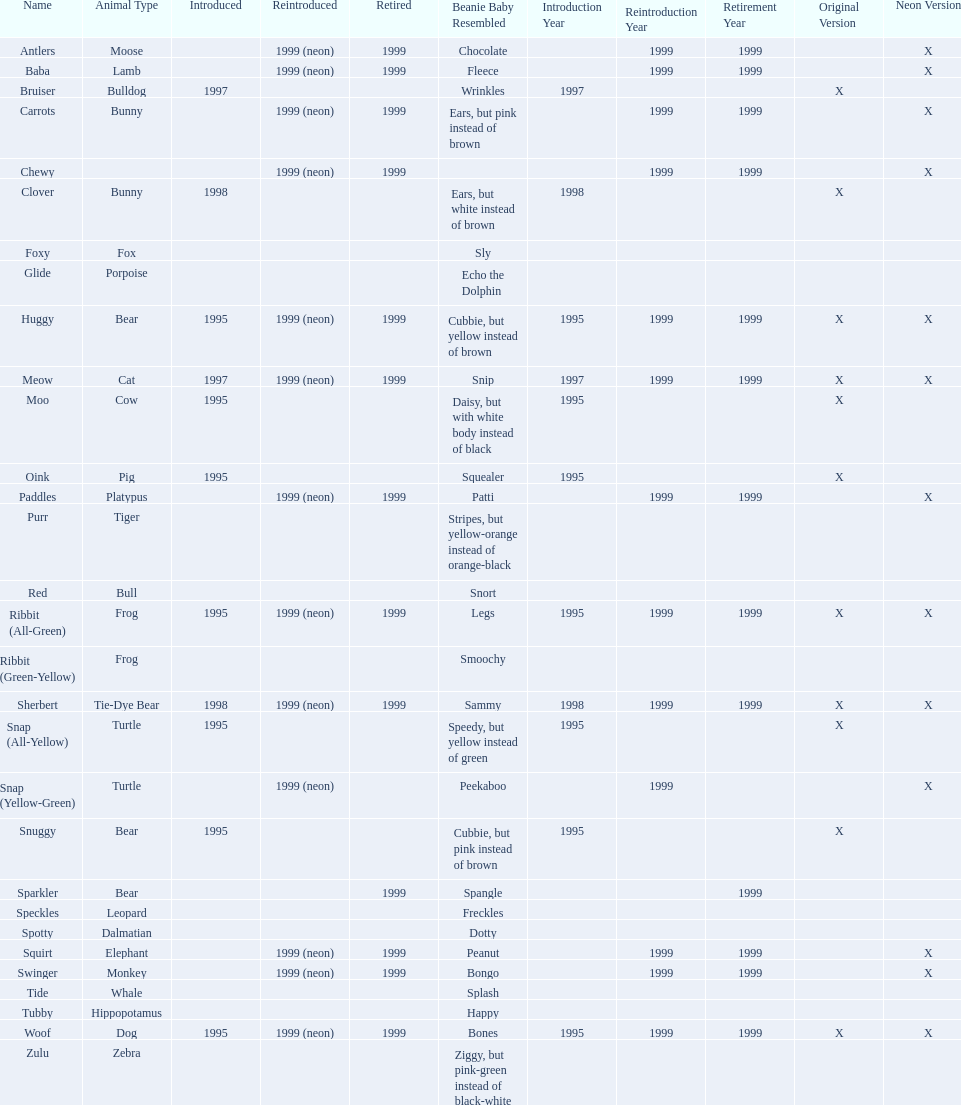What are all the different names of the pillow pals? Antlers, Baba, Bruiser, Carrots, Chewy, Clover, Foxy, Glide, Huggy, Meow, Moo, Oink, Paddles, Purr, Red, Ribbit (All-Green), Ribbit (Green-Yellow), Sherbert, Snap (All-Yellow), Snap (Yellow-Green), Snuggy, Sparkler, Speckles, Spotty, Squirt, Swinger, Tide, Tubby, Woof, Zulu. Would you be able to parse every entry in this table? {'header': ['Name', 'Animal Type', 'Introduced', 'Reintroduced', 'Retired', 'Beanie Baby Resembled', 'Introduction Year', 'Reintroduction Year', 'Retirement Year', 'Original Version', 'Neon Version'], 'rows': [['Antlers', 'Moose', '', '1999 (neon)', '1999', 'Chocolate', '', '1999', '1999', '', 'X'], ['Baba', 'Lamb', '', '1999 (neon)', '1999', 'Fleece', '', '1999', '1999', '', 'X'], ['Bruiser', 'Bulldog', '1997', '', '', 'Wrinkles', '1997', '', '', 'X', ''], ['Carrots', 'Bunny', '', '1999 (neon)', '1999', 'Ears, but pink instead of brown', '', '1999', '1999', '', 'X'], ['Chewy', '', '', '1999 (neon)', '1999', '', '', '1999', '1999', '', 'X'], ['Clover', 'Bunny', '1998', '', '', 'Ears, but white instead of brown', '1998', '', '', 'X', ''], ['Foxy', 'Fox', '', '', '', 'Sly', '', '', '', '', ''], ['Glide', 'Porpoise', '', '', '', 'Echo the Dolphin', '', '', '', '', ''], ['Huggy', 'Bear', '1995', '1999 (neon)', '1999', 'Cubbie, but yellow instead of brown', '1995', '1999', '1999', 'X', 'X'], ['Meow', 'Cat', '1997', '1999 (neon)', '1999', 'Snip', '1997', '1999', '1999', 'X', 'X'], ['Moo', 'Cow', '1995', '', '', 'Daisy, but with white body instead of black', '1995', '', '', 'X', ''], ['Oink', 'Pig', '1995', '', '', 'Squealer', '1995', '', '', 'X', ''], ['Paddles', 'Platypus', '', '1999 (neon)', '1999', 'Patti', '', '1999', '1999', '', 'X'], ['Purr', 'Tiger', '', '', '', 'Stripes, but yellow-orange instead of orange-black', '', '', '', '', ''], ['Red', 'Bull', '', '', '', 'Snort', '', '', '', '', ''], ['Ribbit (All-Green)', 'Frog', '1995', '1999 (neon)', '1999', 'Legs', '1995', '1999', '1999', 'X', 'X'], ['Ribbit (Green-Yellow)', 'Frog', '', '', '', 'Smoochy', '', '', '', '', ''], ['Sherbert', 'Tie-Dye Bear', '1998', '1999 (neon)', '1999', 'Sammy', '1998', '1999', '1999', 'X', 'X'], ['Snap (All-Yellow)', 'Turtle', '1995', '', '', 'Speedy, but yellow instead of green', '1995', '', '', 'X', ''], ['Snap (Yellow-Green)', 'Turtle', '', '1999 (neon)', '', 'Peekaboo', '', '1999', '', '', 'X'], ['Snuggy', 'Bear', '1995', '', '', 'Cubbie, but pink instead of brown', '1995', '', '', 'X', ''], ['Sparkler', 'Bear', '', '', '1999', 'Spangle', '', '', '1999', '', ''], ['Speckles', 'Leopard', '', '', '', 'Freckles', '', '', '', '', ''], ['Spotty', 'Dalmatian', '', '', '', 'Dotty', '', '', '', '', ''], ['Squirt', 'Elephant', '', '1999 (neon)', '1999', 'Peanut', '', '1999', '1999', '', 'X'], ['Swinger', 'Monkey', '', '1999 (neon)', '1999', 'Bongo', '', '1999', '1999', '', 'X'], ['Tide', 'Whale', '', '', '', 'Splash', '', '', '', '', ''], ['Tubby', 'Hippopotamus', '', '', '', 'Happy', '', '', '', '', ''], ['Woof', 'Dog', '1995', '1999 (neon)', '1999', 'Bones', '1995', '1999', '1999', 'X', 'X'], ['Zulu', 'Zebra', '', '', '', 'Ziggy, but pink-green instead of black-white', '', '', '', '', '']]} Which of these are a dalmatian? Spotty. 